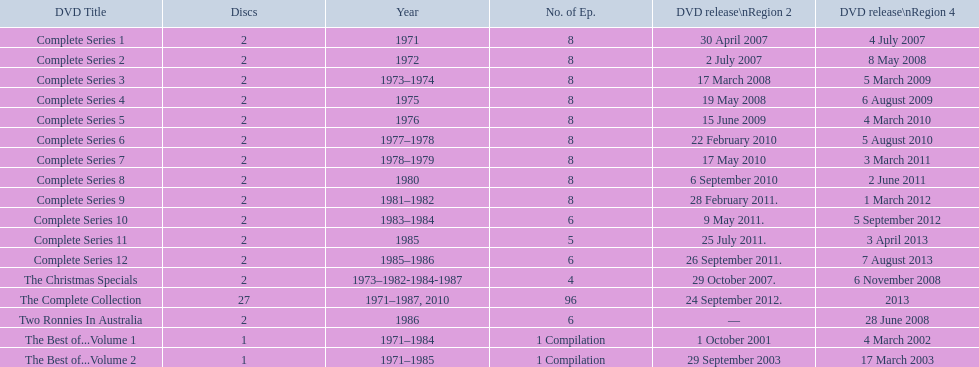Give me the full table as a dictionary. {'header': ['DVD Title', 'Discs', 'Year', 'No. of Ep.', 'DVD release\\nRegion 2', 'DVD release\\nRegion 4'], 'rows': [['Complete Series 1', '2', '1971', '8', '30 April 2007', '4 July 2007'], ['Complete Series 2', '2', '1972', '8', '2 July 2007', '8 May 2008'], ['Complete Series 3', '2', '1973–1974', '8', '17 March 2008', '5 March 2009'], ['Complete Series 4', '2', '1975', '8', '19 May 2008', '6 August 2009'], ['Complete Series 5', '2', '1976', '8', '15 June 2009', '4 March 2010'], ['Complete Series 6', '2', '1977–1978', '8', '22 February 2010', '5 August 2010'], ['Complete Series 7', '2', '1978–1979', '8', '17 May 2010', '3 March 2011'], ['Complete Series 8', '2', '1980', '8', '6 September 2010', '2 June 2011'], ['Complete Series 9', '2', '1981–1982', '8', '28 February 2011.', '1 March 2012'], ['Complete Series 10', '2', '1983–1984', '6', '9 May 2011.', '5 September 2012'], ['Complete Series 11', '2', '1985', '5', '25 July 2011.', '3 April 2013'], ['Complete Series 12', '2', '1985–1986', '6', '26 September 2011.', '7 August 2013'], ['The Christmas Specials', '2', '1973–1982-1984-1987', '4', '29 October 2007.', '6 November 2008'], ['The Complete Collection', '27', '1971–1987, 2010', '96', '24 September 2012.', '2013'], ['Two Ronnies In Australia', '2', '1986', '6', '—', '28 June 2008'], ['The Best of...Volume 1', '1', '1971–1984', '1 Compilation', '1 October 2001', '4 March 2002'], ['The Best of...Volume 2', '1', '1971–1985', '1 Compilation', '29 September 2003', '17 March 2003']]} What is the total of all dics listed in the table? 57. 